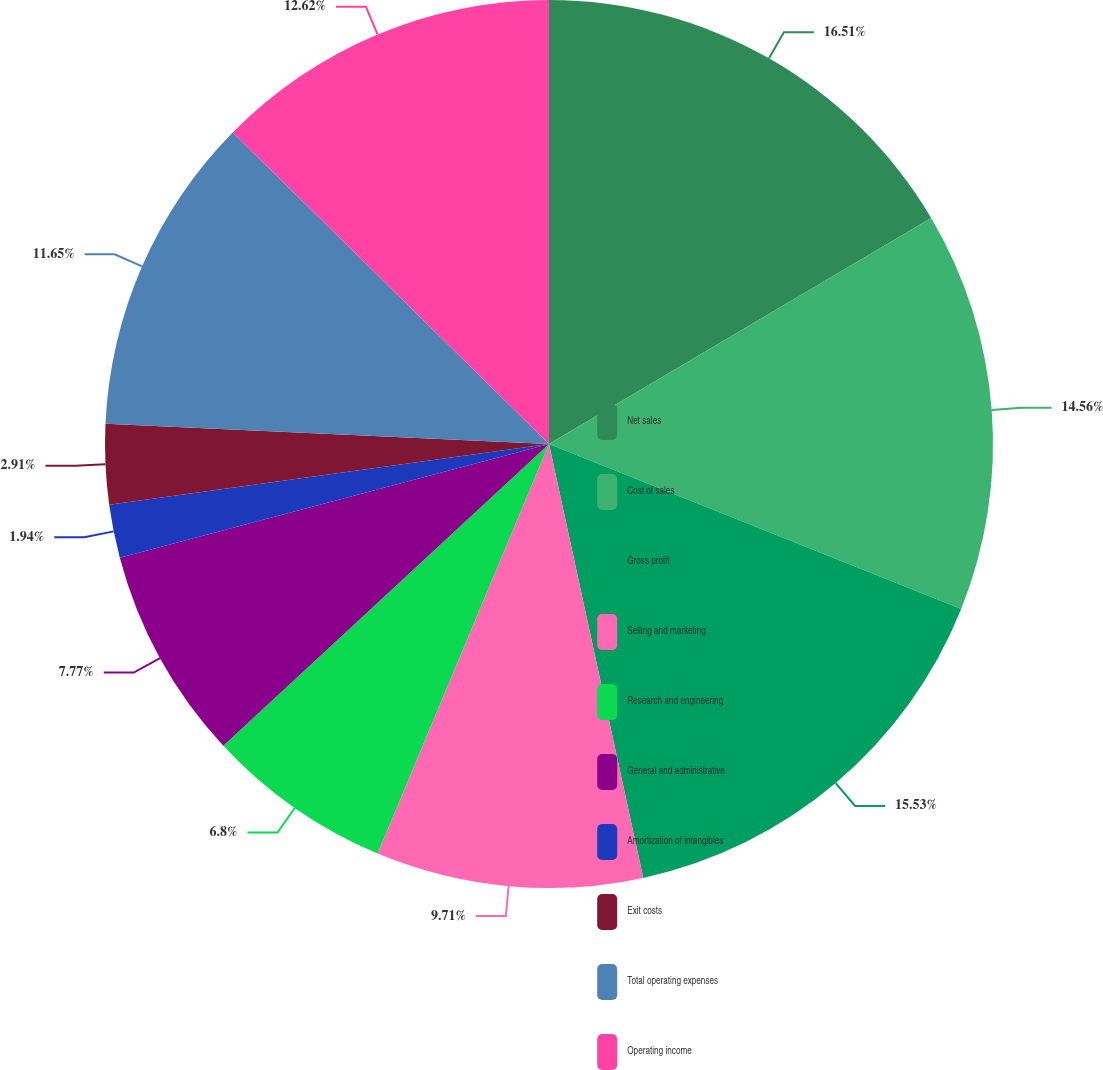Convert chart. <chart><loc_0><loc_0><loc_500><loc_500><pie_chart><fcel>Net sales<fcel>Cost of sales<fcel>Gross profit<fcel>Selling and marketing<fcel>Research and engineering<fcel>General and administrative<fcel>Amortization of intangibles<fcel>Exit costs<fcel>Total operating expenses<fcel>Operating income<nl><fcel>16.5%<fcel>14.56%<fcel>15.53%<fcel>9.71%<fcel>6.8%<fcel>7.77%<fcel>1.94%<fcel>2.91%<fcel>11.65%<fcel>12.62%<nl></chart> 